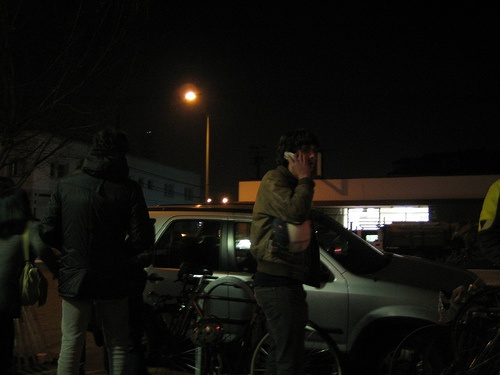Describe the objects in this image and their specific colors. I can see people in black and darkgreen tones, car in black, gray, and darkgreen tones, people in black, maroon, darkgreen, and olive tones, bicycle in black and darkgreen tones, and people in black, darkgreen, and gray tones in this image. 